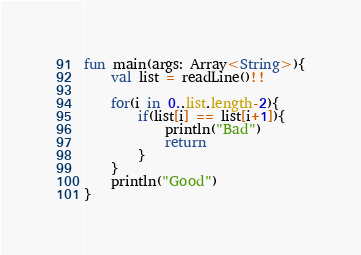<code> <loc_0><loc_0><loc_500><loc_500><_Kotlin_>fun main(args: Array<String>){
    val list = readLine()!!

    for(i in 0..list.length-2){
        if(list[i] == list[i+1]){
            println("Bad")
            return
        }
    }
    println("Good")
}</code> 